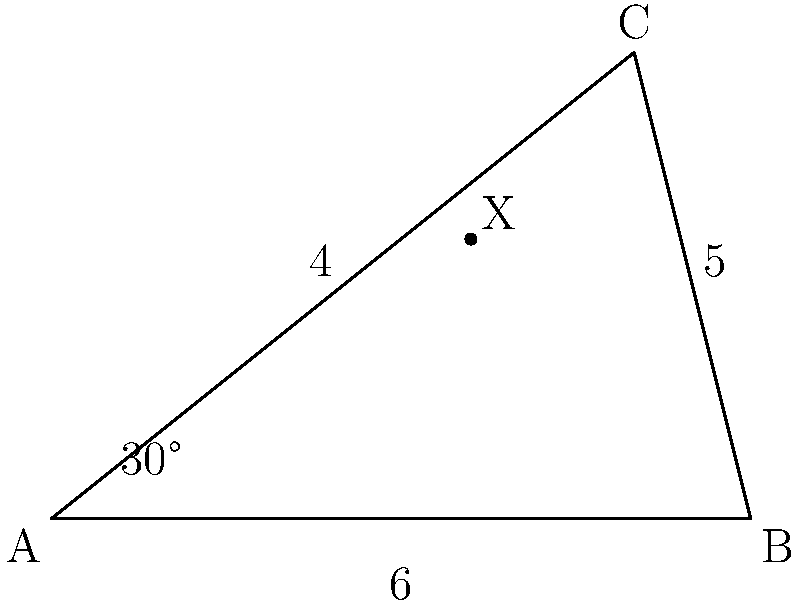You're trying to determine if there's a hidden alley with potential parking between two streets in the city. The streets form a triangle ABC as shown in the diagram. Given that angle BAC is 30°, AB is 6 units long, and BC is 5 units long, what is the measure of angle ABC to the nearest degree? To find angle ABC, we can use the law of cosines. Here's how:

1) The law of cosines states: $c^2 = a^2 + b^2 - 2ab \cos(C)$

   Where $c$ is the side opposite to angle $C$, and $a$ and $b$ are the other two sides.

2) In our triangle:
   $c = AC$ (unknown)
   $a = BC = 5$
   $b = AB = 6$
   $C = 30°$

3) Let's substitute these into the formula:
   $AC^2 = 5^2 + 6^2 - 2(5)(6)\cos(30°)$

4) Simplify:
   $AC^2 = 25 + 36 - 60\cos(30°)$
   $AC^2 = 61 - 60(\frac{\sqrt{3}}{2})$
   $AC^2 = 61 - 30\sqrt{3}$

5) Now we know all three sides of the triangle. We can use the law of cosines again to find angle ABC:

   $\cos(ABC) = \frac{AC^2 + AB^2 - BC^2}{2(AC)(AB)}$

6) Substitute the values:
   $\cos(ABC) = \frac{(61 - 30\sqrt{3}) + 6^2 - 5^2}{2\sqrt{61 - 30\sqrt{3}}(6)}$

7) Simplify:
   $\cos(ABC) = \frac{61 - 30\sqrt{3} + 36 - 25}{2\sqrt{61 - 30\sqrt{3}}(6)}$
   $\cos(ABC) = \frac{72 - 30\sqrt{3}}{12\sqrt{61 - 30\sqrt{3}}}$

8) Use inverse cosine (arccos) to get the angle:
   $ABC = \arccos(\frac{72 - 30\sqrt{3}}{12\sqrt{61 - 30\sqrt{3}}})$

9) Calculate this value and round to the nearest degree:
   $ABC \approx 101°$
Answer: 101° 